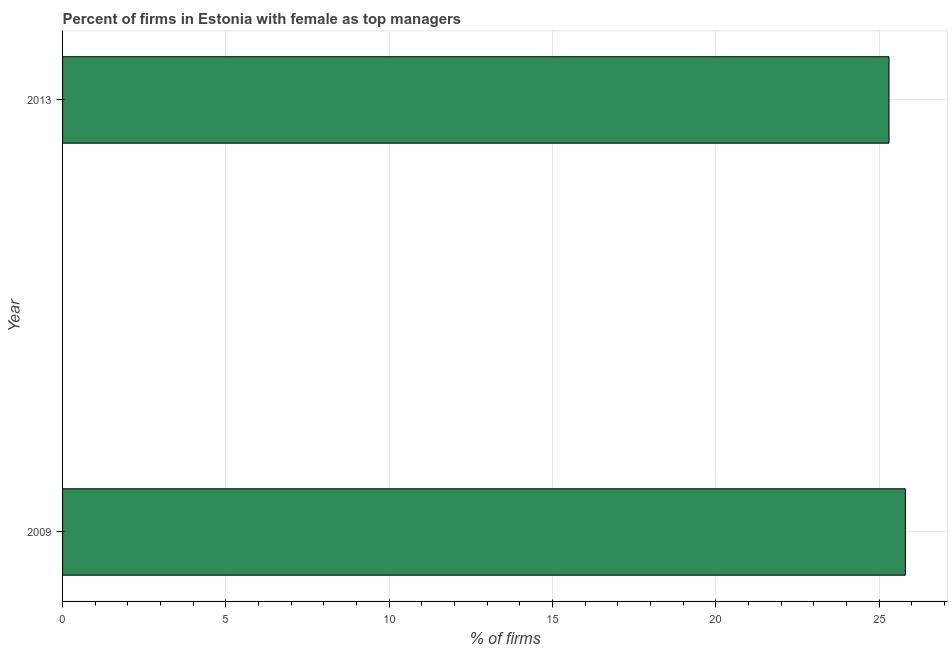What is the title of the graph?
Provide a succinct answer. Percent of firms in Estonia with female as top managers. What is the label or title of the X-axis?
Give a very brief answer. % of firms. What is the label or title of the Y-axis?
Make the answer very short. Year. What is the percentage of firms with female as top manager in 2009?
Your response must be concise. 25.8. Across all years, what is the maximum percentage of firms with female as top manager?
Offer a very short reply. 25.8. Across all years, what is the minimum percentage of firms with female as top manager?
Offer a very short reply. 25.3. In which year was the percentage of firms with female as top manager maximum?
Provide a short and direct response. 2009. What is the sum of the percentage of firms with female as top manager?
Offer a very short reply. 51.1. What is the difference between the percentage of firms with female as top manager in 2009 and 2013?
Your answer should be very brief. 0.5. What is the average percentage of firms with female as top manager per year?
Provide a short and direct response. 25.55. What is the median percentage of firms with female as top manager?
Your response must be concise. 25.55. Do a majority of the years between 2009 and 2013 (inclusive) have percentage of firms with female as top manager greater than 13 %?
Offer a terse response. Yes. What is the ratio of the percentage of firms with female as top manager in 2009 to that in 2013?
Offer a very short reply. 1.02. In how many years, is the percentage of firms with female as top manager greater than the average percentage of firms with female as top manager taken over all years?
Ensure brevity in your answer.  1. How many bars are there?
Offer a very short reply. 2. How many years are there in the graph?
Your answer should be very brief. 2. What is the difference between two consecutive major ticks on the X-axis?
Offer a very short reply. 5. What is the % of firms of 2009?
Provide a succinct answer. 25.8. What is the % of firms of 2013?
Provide a succinct answer. 25.3. What is the difference between the % of firms in 2009 and 2013?
Your response must be concise. 0.5. 